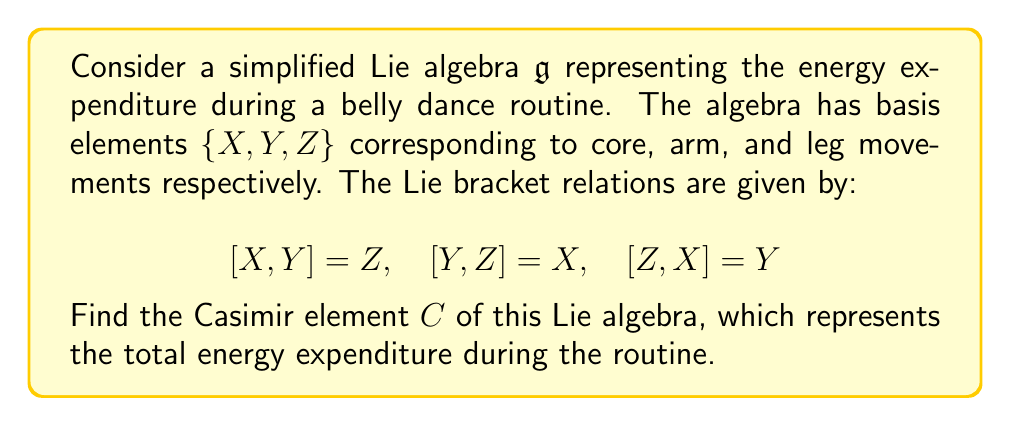Can you answer this question? To find the Casimir element of this Lie algebra, we'll follow these steps:

1) The Casimir element is of the form $C = aX^2 + bY^2 + cZ^2$, where $a$, $b$, and $c$ are constants to be determined.

2) For $C$ to be a Casimir element, it must commute with all elements of the algebra. We'll check this condition with each basis element.

3) For $X$:
   $$[C,X] = [aX^2 + bY^2 + cZ^2, X] = b[Y^2,X] + c[Z^2,X]$$
   $$= b(YZY - YYZ) + c(ZXZ - ZZX) = b(YZ - ZY) + c(XZ - ZX) = bY - cY = (b-c)Y$$

4) For $Y$:
   $$[C,Y] = [aX^2 + bY^2 + cZ^2, Y] = a[X^2,Y] + c[Z^2,Y]$$
   $$= a(XYX - XXY) + c(ZYZ - ZZY) = a(YX - XY) + c(XZ - ZX) = -aZ + cZ = (c-a)Z$$

5) For $Z$:
   $$[C,Z] = [aX^2 + bY^2 + cZ^2, Z] = a[X^2,Z] + b[Y^2,Z]$$
   $$= a(XZX - XXZ) + b(YZY - YYZ) = a(ZX - XZ) + b(XY - YX) = -aY + bX = (b-a)X$$

6) For $C$ to commute with all elements, we need:
   $b-c = 0$, $c-a = 0$, and $b-a = 0$

7) This system of equations has the solution $a = b = c$

Therefore, the Casimir element is of the form:

$$C = a(X^2 + Y^2 + Z^2)$$

where $a$ is an arbitrary constant. We can choose $a=1$ for simplicity.
Answer: The Casimir element is $C = X^2 + Y^2 + Z^2$. 